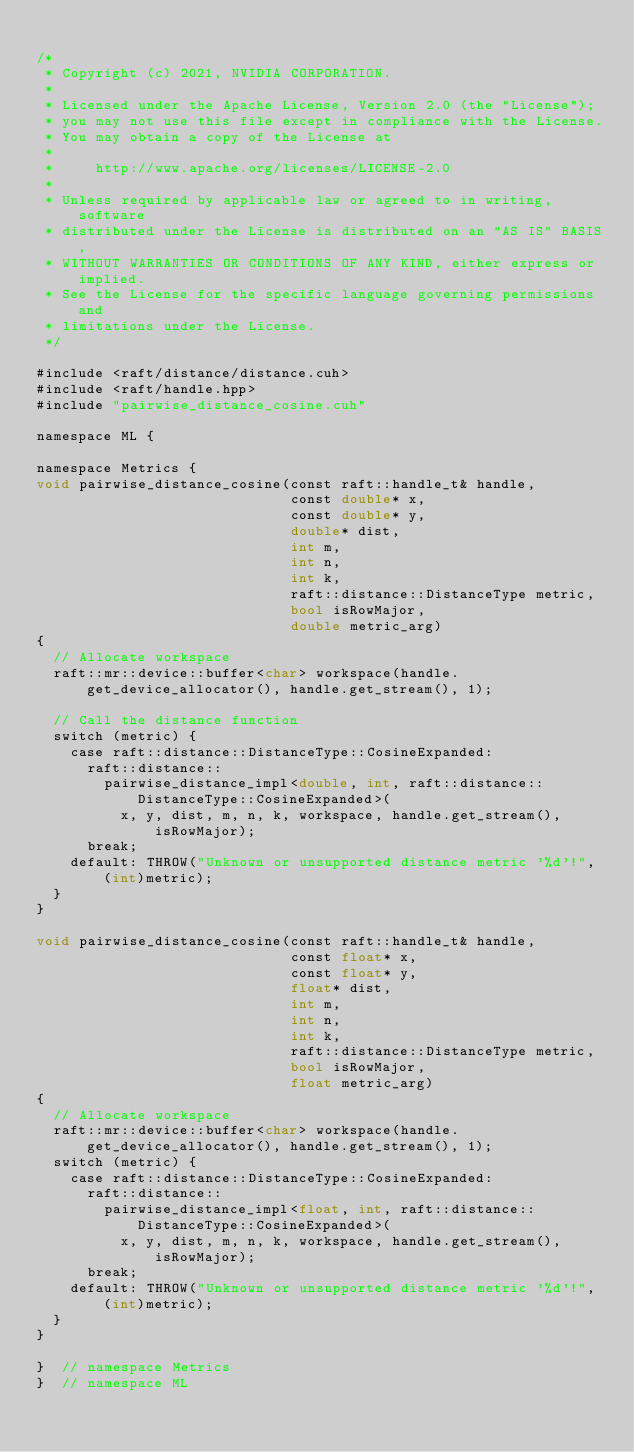Convert code to text. <code><loc_0><loc_0><loc_500><loc_500><_Cuda_>
/*
 * Copyright (c) 2021, NVIDIA CORPORATION.
 *
 * Licensed under the Apache License, Version 2.0 (the "License");
 * you may not use this file except in compliance with the License.
 * You may obtain a copy of the License at
 *
 *     http://www.apache.org/licenses/LICENSE-2.0
 *
 * Unless required by applicable law or agreed to in writing, software
 * distributed under the License is distributed on an "AS IS" BASIS,
 * WITHOUT WARRANTIES OR CONDITIONS OF ANY KIND, either express or implied.
 * See the License for the specific language governing permissions and
 * limitations under the License.
 */

#include <raft/distance/distance.cuh>
#include <raft/handle.hpp>
#include "pairwise_distance_cosine.cuh"

namespace ML {

namespace Metrics {
void pairwise_distance_cosine(const raft::handle_t& handle,
                              const double* x,
                              const double* y,
                              double* dist,
                              int m,
                              int n,
                              int k,
                              raft::distance::DistanceType metric,
                              bool isRowMajor,
                              double metric_arg)
{
  // Allocate workspace
  raft::mr::device::buffer<char> workspace(handle.get_device_allocator(), handle.get_stream(), 1);

  // Call the distance function
  switch (metric) {
    case raft::distance::DistanceType::CosineExpanded:
      raft::distance::
        pairwise_distance_impl<double, int, raft::distance::DistanceType::CosineExpanded>(
          x, y, dist, m, n, k, workspace, handle.get_stream(), isRowMajor);
      break;
    default: THROW("Unknown or unsupported distance metric '%d'!", (int)metric);
  }
}

void pairwise_distance_cosine(const raft::handle_t& handle,
                              const float* x,
                              const float* y,
                              float* dist,
                              int m,
                              int n,
                              int k,
                              raft::distance::DistanceType metric,
                              bool isRowMajor,
                              float metric_arg)
{
  // Allocate workspace
  raft::mr::device::buffer<char> workspace(handle.get_device_allocator(), handle.get_stream(), 1);
  switch (metric) {
    case raft::distance::DistanceType::CosineExpanded:
      raft::distance::
        pairwise_distance_impl<float, int, raft::distance::DistanceType::CosineExpanded>(
          x, y, dist, m, n, k, workspace, handle.get_stream(), isRowMajor);
      break;
    default: THROW("Unknown or unsupported distance metric '%d'!", (int)metric);
  }
}

}  // namespace Metrics
}  // namespace ML
</code> 